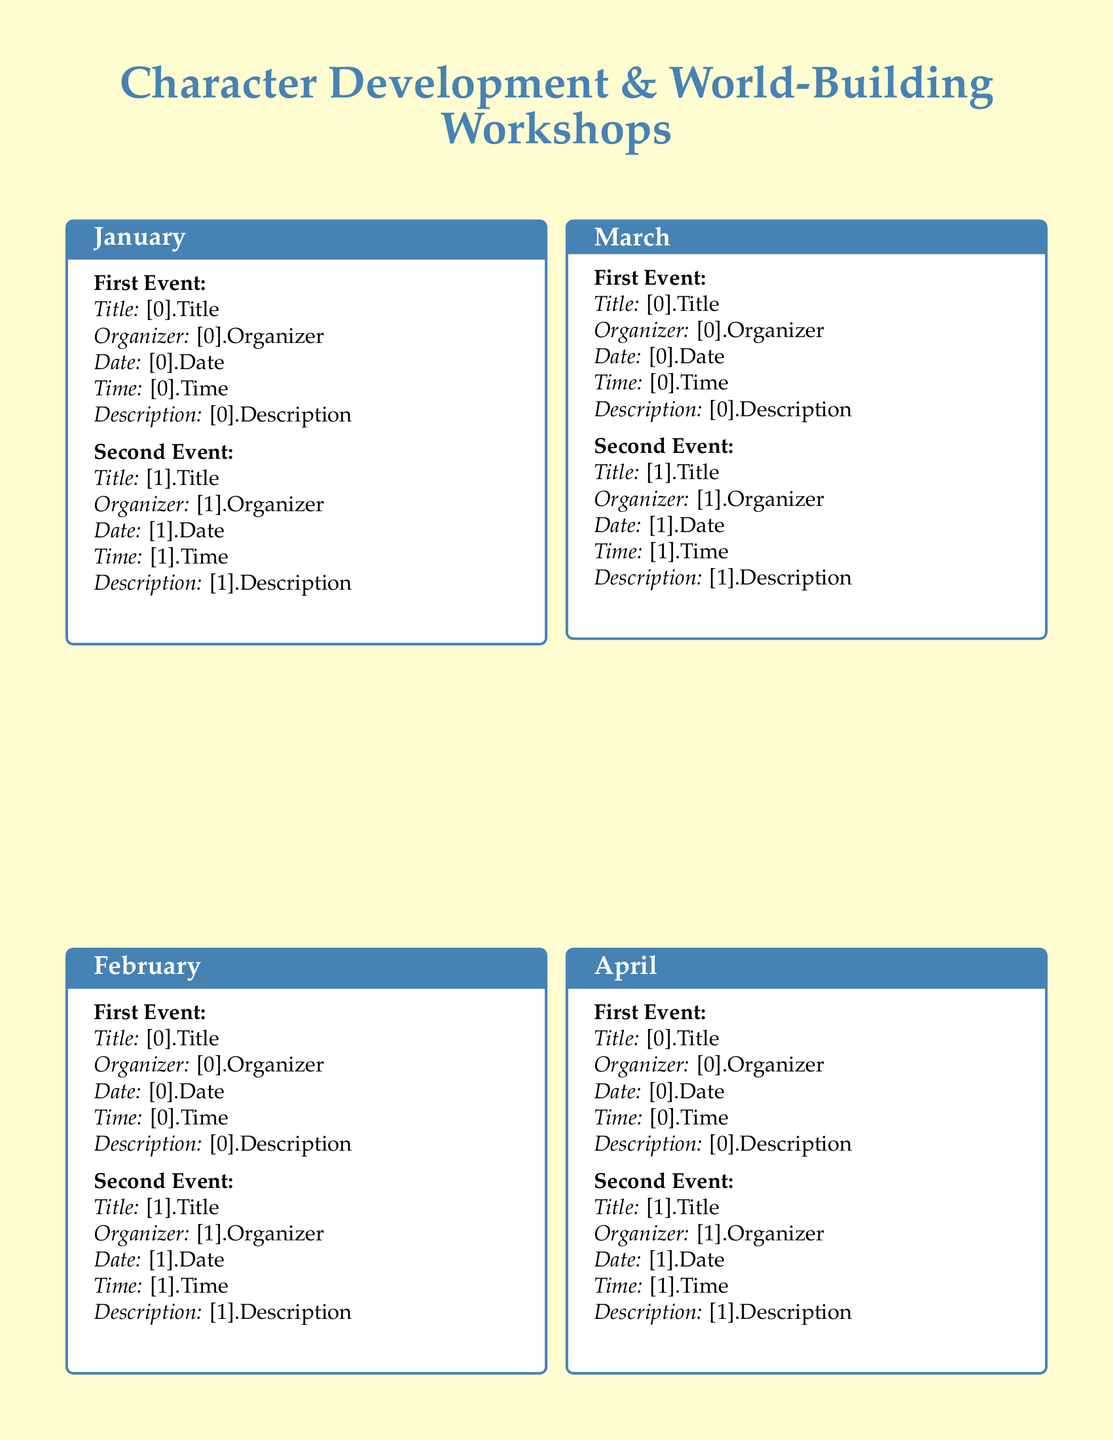What is the title of the first event in January? The first event's title in January is explicitly stated in the document.
Answer: Introduction to Character Development Who organizes the March 22 event? The document lists the organizer of the March 22 event under its description.
Answer: Imaginative Writers Collective What is the date of the second event in February? The document includes specific dates for each event, found under the February section.
Answer: February 25 How many events are scheduled for April? The number of events mentioned in the April section indicates how many are happening that month.
Answer: 2 What is the time of the April 27 event? The specific time for the April 27 event can be found in the event description.
Answer: 3:00 PM - 5:00 PM Which month features a workshop on dialogue? The month containing a workshop on writing dialogue can be located by scanning through the event titles.
Answer: April What is the theme of the May 15 workshop? The document provides titles and themes for each workshop, allowing for easy retrieval of this information.
Answer: Advanced Character Development Which event focuses on world mythology? The title of the event that discusses mythical elements can be discerned from the event list.
Answer: Mythopoeia and World Mythology 